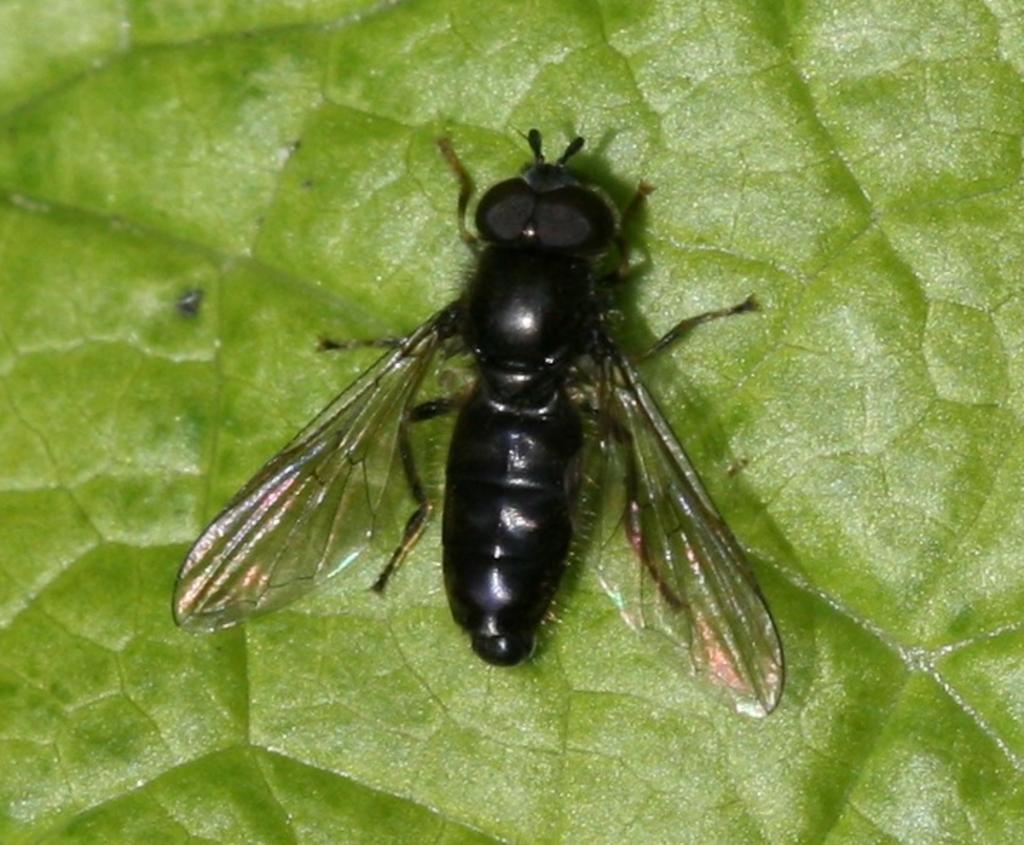Please provide a concise description of this image. In this picture I can see there is a bee, sitting on the leaf and it has wings, head, body and legs. It is in black color. 